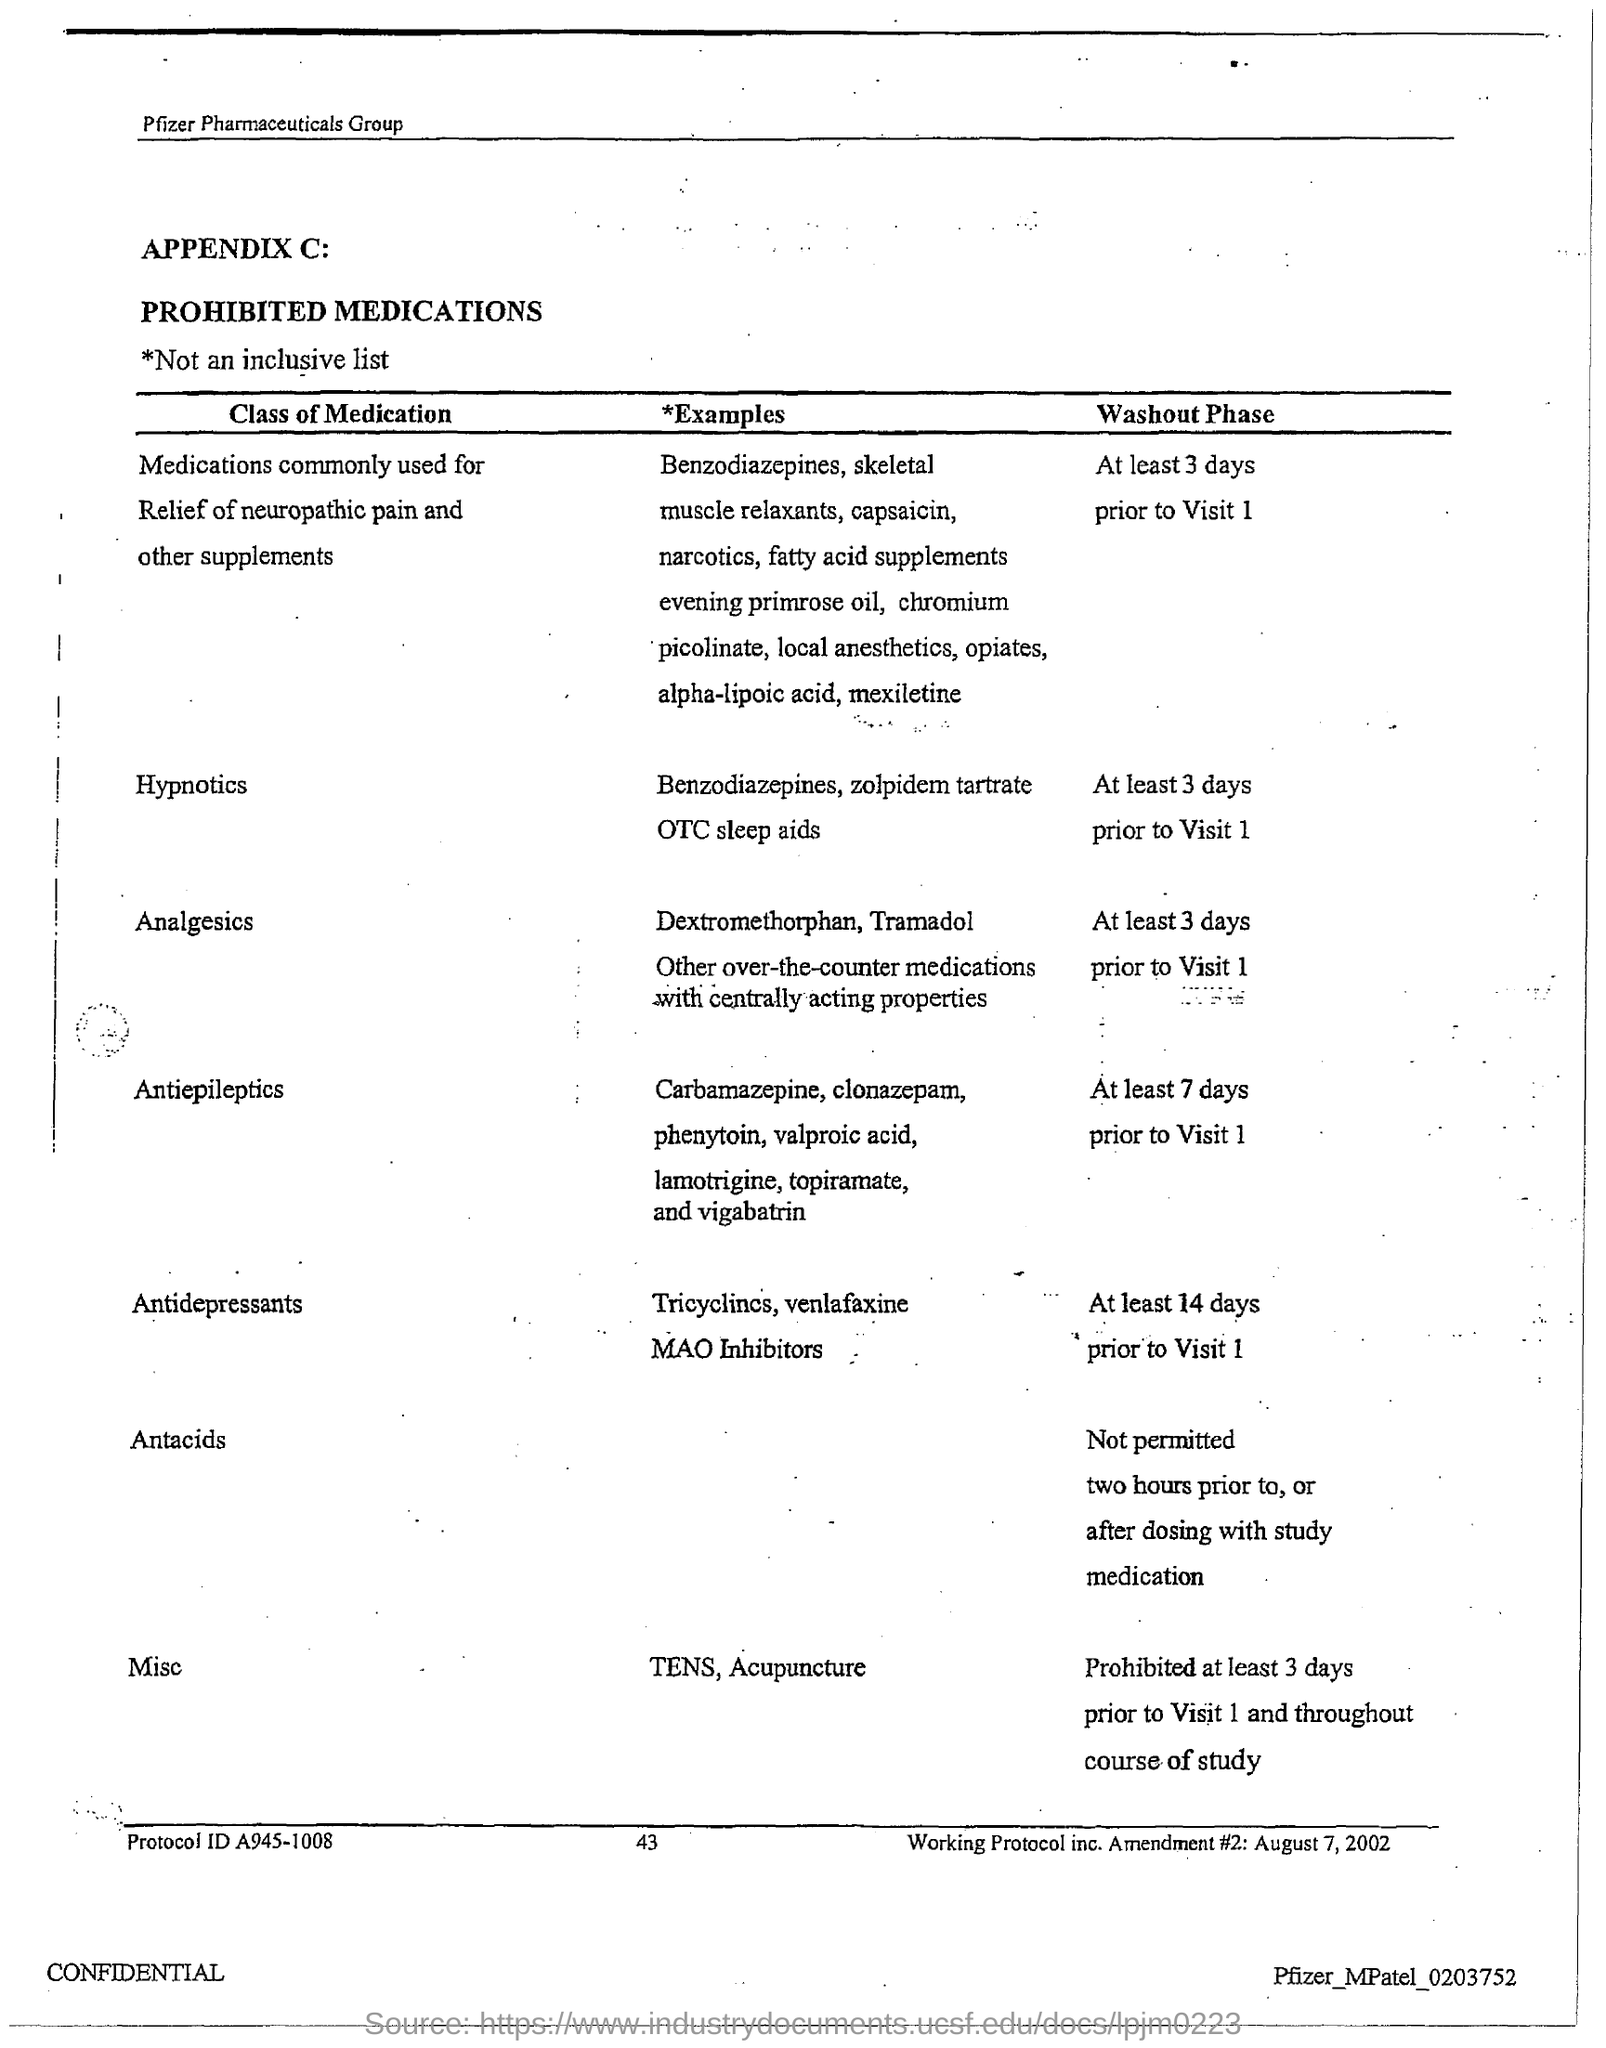What is the page no mentioned in this document?
Your answer should be very brief. 43. What is the Protocol ID given in the document?
Provide a short and direct response. A945-1008. 